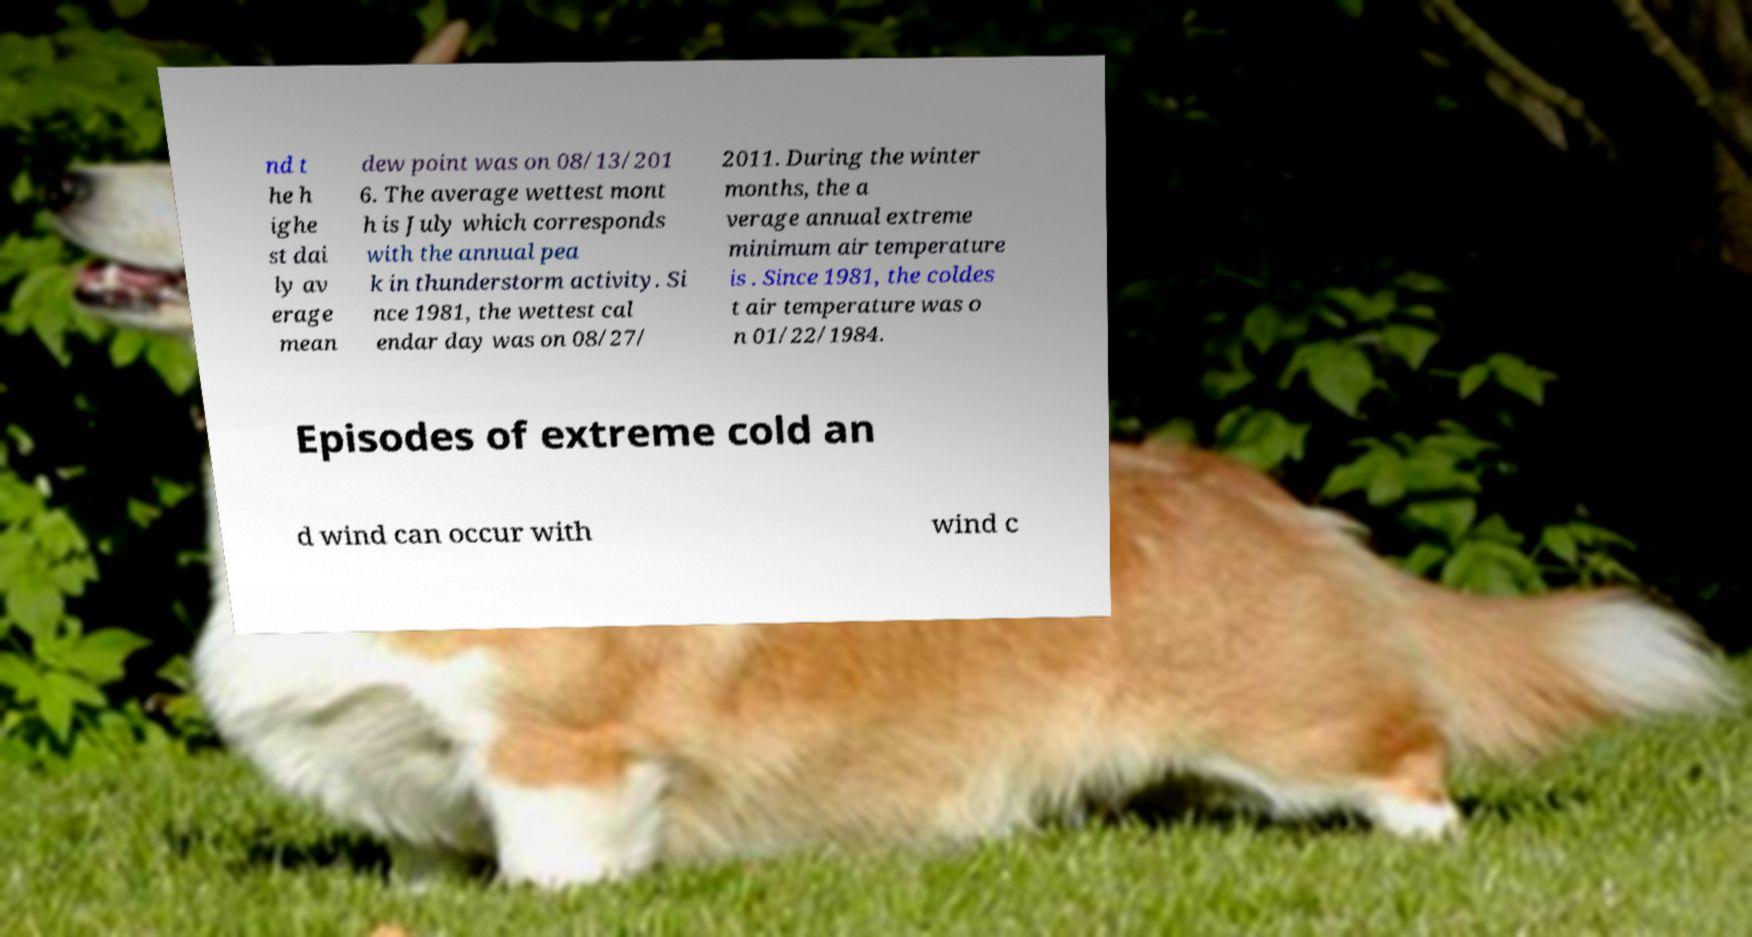Please read and relay the text visible in this image. What does it say? nd t he h ighe st dai ly av erage mean dew point was on 08/13/201 6. The average wettest mont h is July which corresponds with the annual pea k in thunderstorm activity. Si nce 1981, the wettest cal endar day was on 08/27/ 2011. During the winter months, the a verage annual extreme minimum air temperature is . Since 1981, the coldes t air temperature was o n 01/22/1984. Episodes of extreme cold an d wind can occur with wind c 